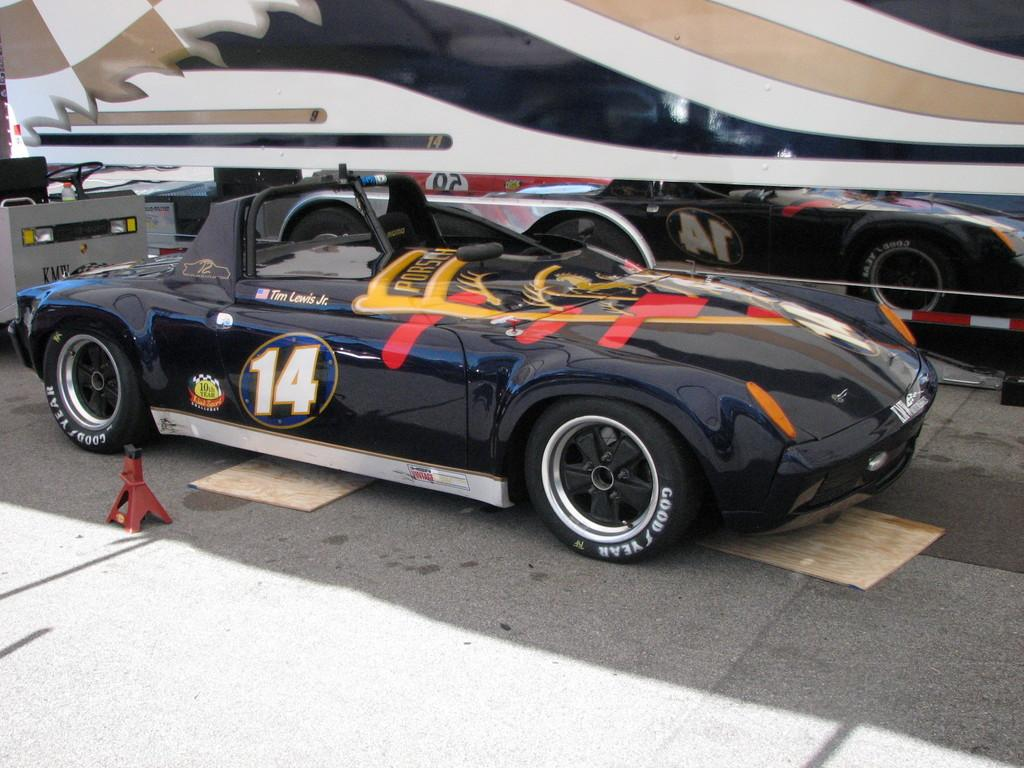<image>
Offer a succinct explanation of the picture presented. A black sports car has the number 14 on its door. 